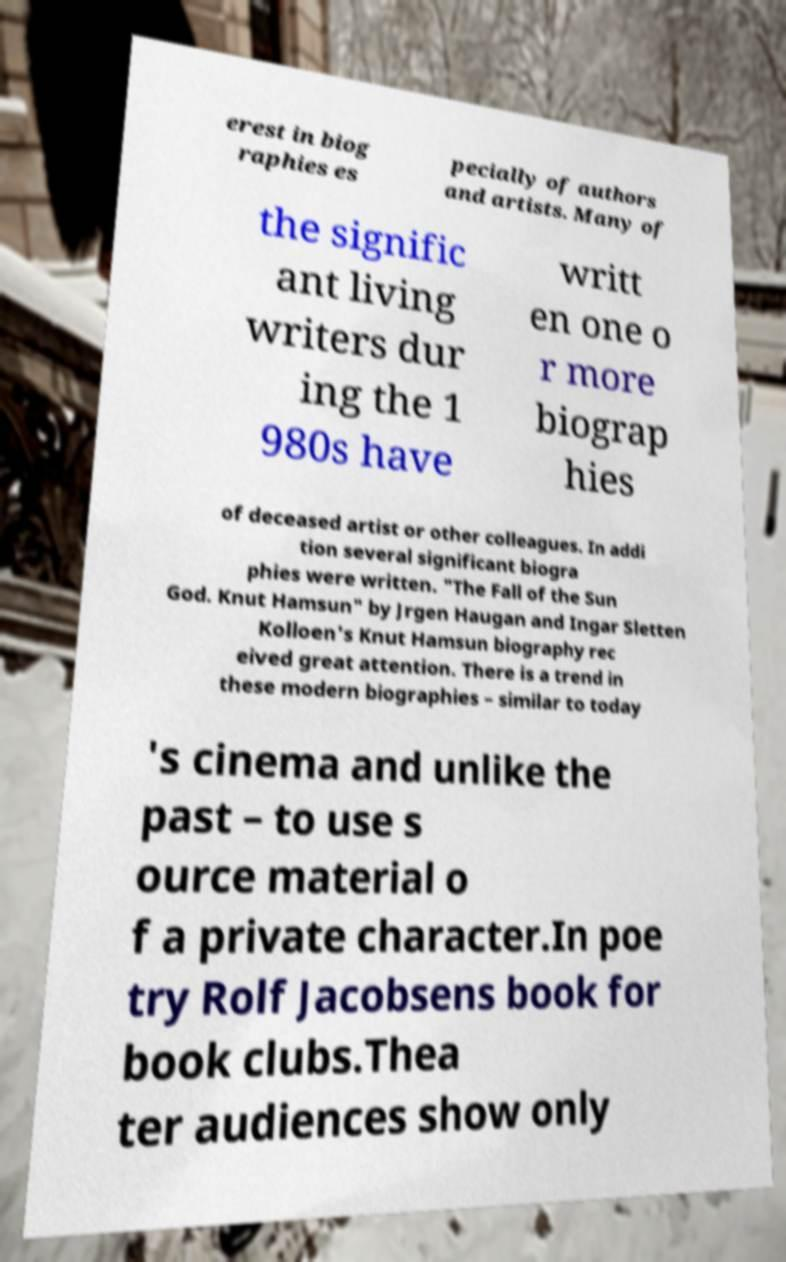I need the written content from this picture converted into text. Can you do that? erest in biog raphies es pecially of authors and artists. Many of the signific ant living writers dur ing the 1 980s have writt en one o r more biograp hies of deceased artist or other colleagues. In addi tion several significant biogra phies were written. "The Fall of the Sun God. Knut Hamsun" by Jrgen Haugan and Ingar Sletten Kolloen's Knut Hamsun biography rec eived great attention. There is a trend in these modern biographies – similar to today 's cinema and unlike the past – to use s ource material o f a private character.In poe try Rolf Jacobsens book for book clubs.Thea ter audiences show only 